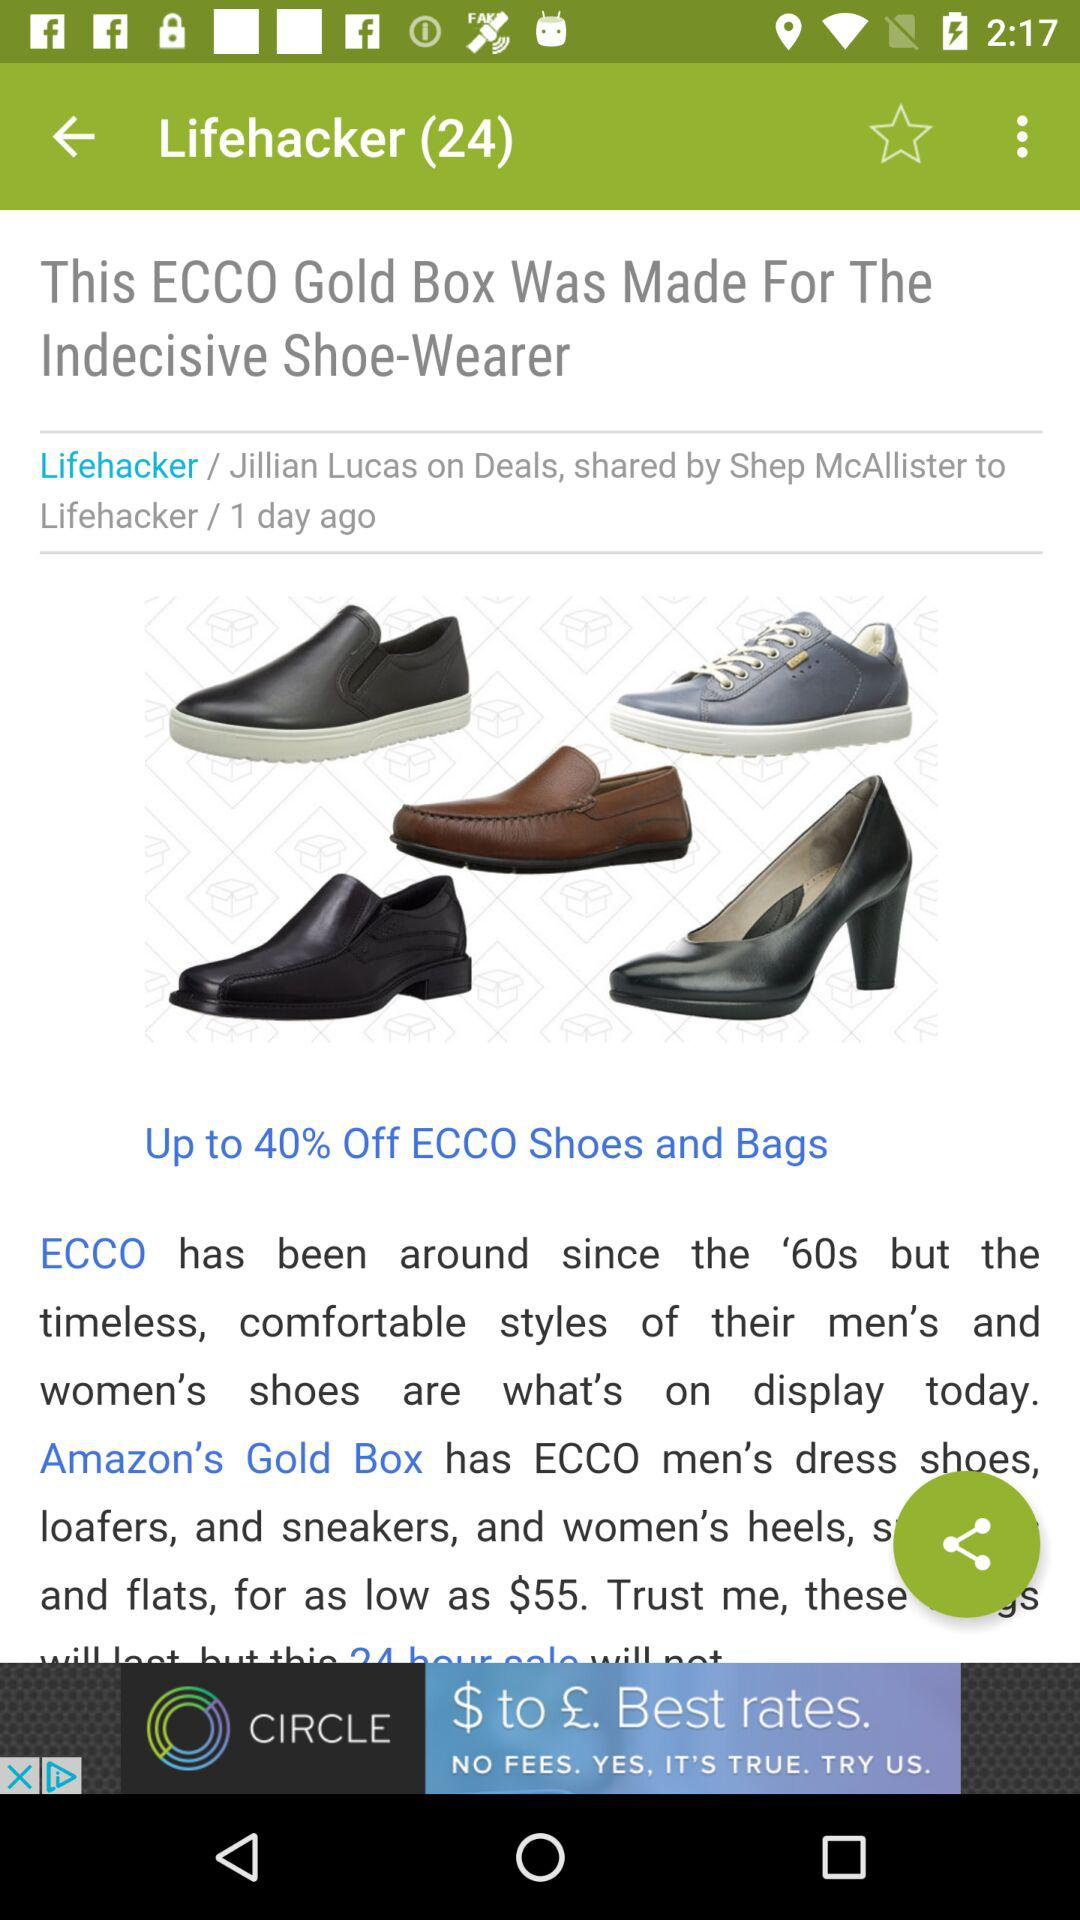What percentage is off on "ECCO" shoes and bags? The percentage off on "ECCO" shoes and bags is up to 40. 